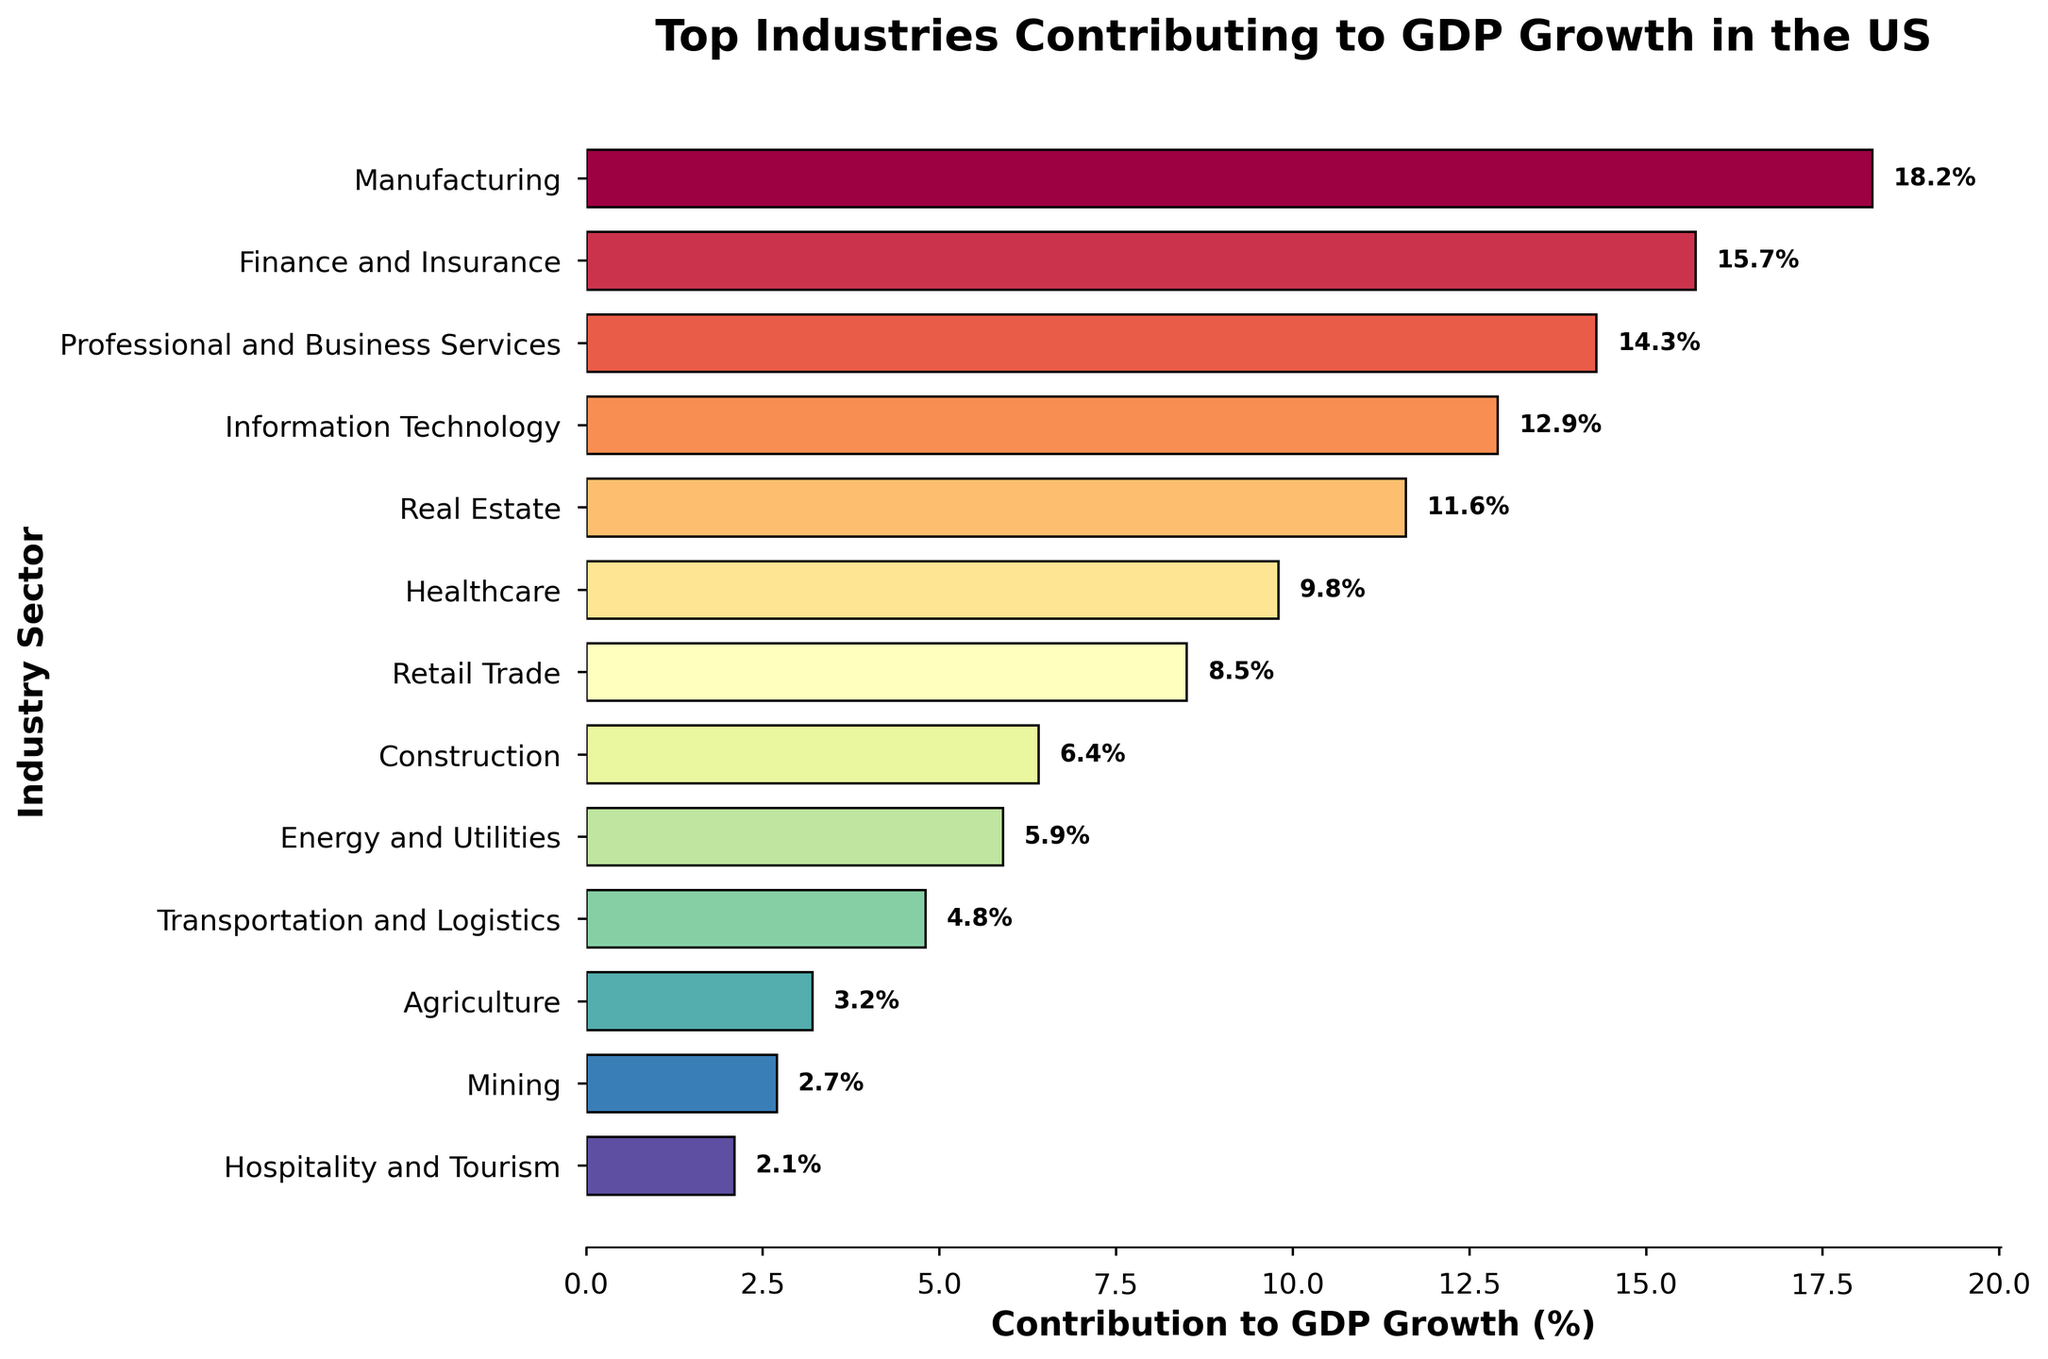Which industry sector contributes the most to GDP growth? The bar chart shows horizontal bars representing the contribution of various industry sectors to GDP growth. The longest bar indicates the sector contributing the most. The manufacturing sector has the longest bar.
Answer: Manufacturing Which sector has a higher contribution to GDP growth, Real Estate or Healthcare? By comparing the lengths of the bars for Real Estate and Healthcare, we see that the Real Estate bar is longer than the Healthcare bar, meaning Real Estate has a higher contribution.
Answer: Real Estate What is the combined contribution to GDP growth of the top three industry sectors? From the chart, the top three sectors are Manufacturing (18.2%), Finance and Insurance (15.7%), and Professional and Business Services (14.3%). Adding these percentages together: 18.2 + 15.7 + 14.3 = 48.2%.
Answer: 48.2% How does the contribution of Mining compare to that of Agriculture? By comparing the length of the bars for Mining and Agriculture, Mining has a slightly shorter bar than Agriculture, indicating a lower contribution.
Answer: Mining contributes less than Agriculture What is the difference in contribution to GDP growth between Information Technology and Retail Trade? The contribution of Information Technology is 12.9%, and Retail Trade is 8.5%. Subtracting these values gives: 12.9 - 8.5 = 4.4%.
Answer: 4.4% Which sectors contribute less than 10% to GDP growth? Sectors with bars that do not reach the 10% mark on the x-axis are less than 10%. These are Healthcare (9.8%), Retail Trade (8.5%), Construction (6.4%), Energy and Utilities (5.9%), Transportation and Logistics (4.8%), Agriculture (3.2%), Mining (2.7%), and Hospitality and Tourism (2.1%).
Answer: Healthcare, Retail Trade, Construction, Energy and Utilities, Transportation and Logistics, Agriculture, Mining, Hospitality and Tourism What proportion of the total contribution to GDP growth is made up by Energy and Utilities and Transportation and Logistics combined? First, sum the contributions of Energy and Utilities (5.9%) and Transportation and Logistics (4.8%), which totals 10.7%. Then sum all the sectors' contributions to get 116.1%. The proportion is 10.7/116.1 ≈ 0.092, and converting this to a percentage gives approximately 9.2%.
Answer: 9.2% If we consider sectors contributing more than 10% to GDP growth, what is their average contribution? The sectors are Manufacturing (18.2%), Finance and Insurance (15.7%), Professional and Business Services (14.3%), Information Technology (12.9%), and Real Estate (11.6%). Their total contribution is 18.2 + 15.7 + 14.3 + 12.9 + 11.6 = 72.7%. The number of sectors is 5. The average is 72.7 / 5 = 14.54%.
Answer: 14.54% What is the contribution difference between the Manufacturing and Hospitality and Tourism sectors? The contribution of Manufacturing is 18.2%, while Hospitality and Tourism is 2.1%. The difference is 18.2 - 2.1 = 16.1%.
Answer: 16.1% How many sectors have contributions greater than or equal to 10%? Counting the bars that extend to or beyond the 10% mark on the x-axis shows five sectors: Manufacturing, Finance and Insurance, Professional and Business Services, Information Technology, and Real Estate.
Answer: 5 